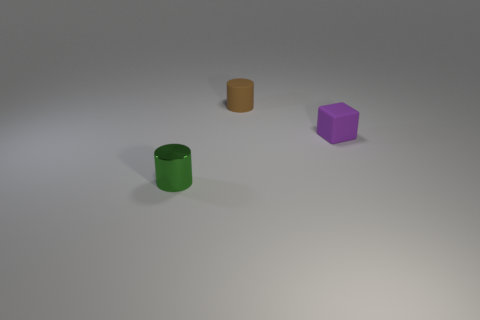Add 2 small purple matte balls. How many objects exist? 5 Subtract 2 cylinders. How many cylinders are left? 0 Subtract all cubes. How many objects are left? 2 Subtract all brown cylinders. How many gray blocks are left? 0 Subtract all tiny gray metal objects. Subtract all small things. How many objects are left? 0 Add 1 small green metal cylinders. How many small green metal cylinders are left? 2 Add 1 tiny purple matte blocks. How many tiny purple matte blocks exist? 2 Subtract all green cylinders. How many cylinders are left? 1 Subtract 0 brown spheres. How many objects are left? 3 Subtract all blue cylinders. Subtract all cyan cubes. How many cylinders are left? 2 